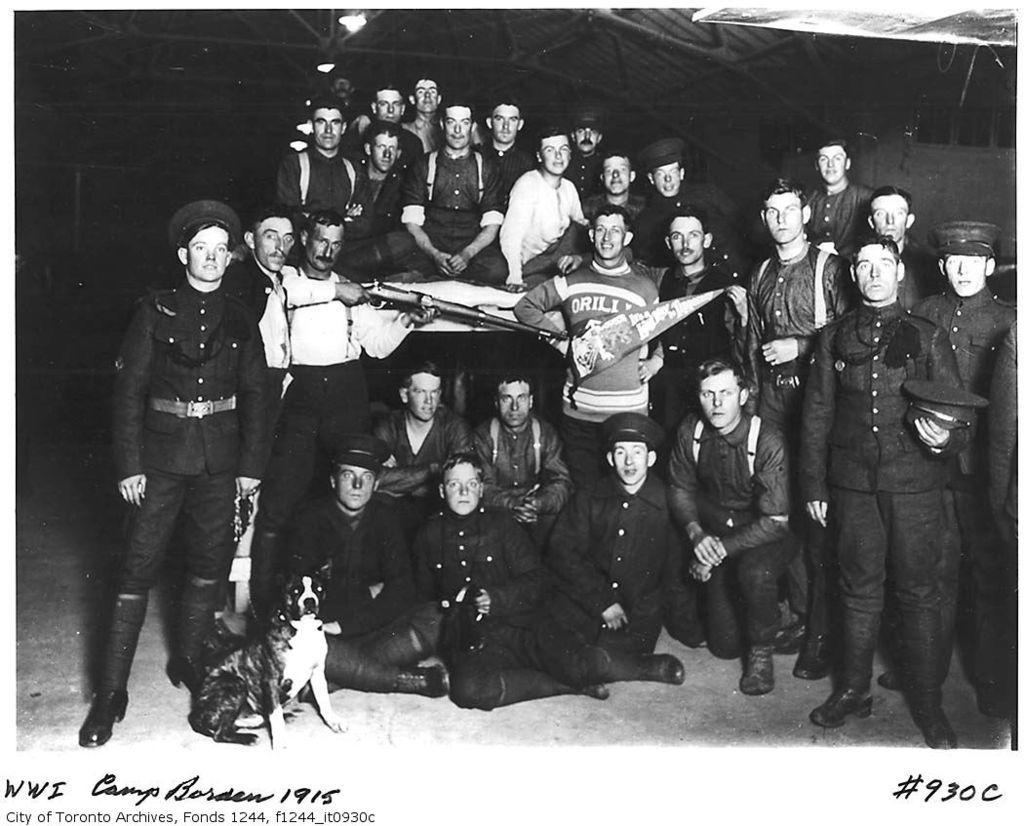What is the color scheme of the image? The image is black and white. Where are the people located in the image? The people are in the center of the image. What type of animal is present in the image? There is a dog in the image. What can be seen in the background of the image? There is a shed in the background of the image. What brand of toothpaste is being advertised in the image? There is no toothpaste or advertisement present in the image. What type of home is shown in the image? The image does not show a home; it only features a shed in the background. 